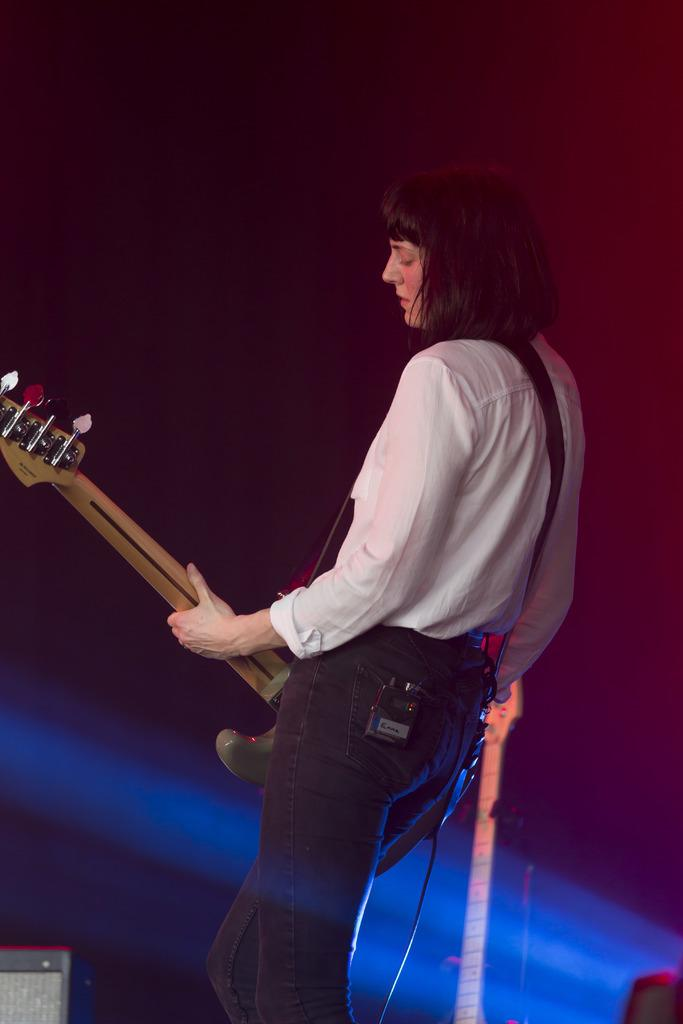Who is the main subject in the image? There is a lady in the image. What is the lady wearing? The lady is wearing a white shirt. What is the lady holding in the image? The lady is holding a guitar. Where is the lady located in the image? The lady is in the middle of the image. What can be observed about the background of the image? The background of the image is dark. What type of ring can be seen on the lady's finger in the image? There is no ring visible on the lady's finger in the image. Are there any bears present in the image? There are no bears present in the image. 